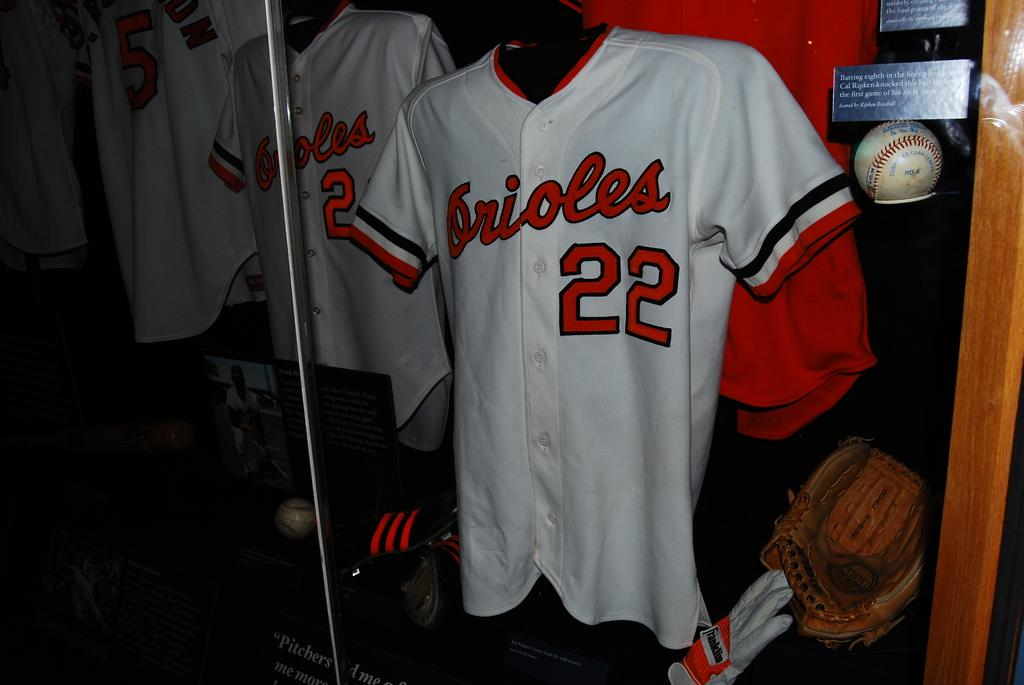<image>
Give a short and clear explanation of the subsequent image. a jersey that has the number 22 on it 